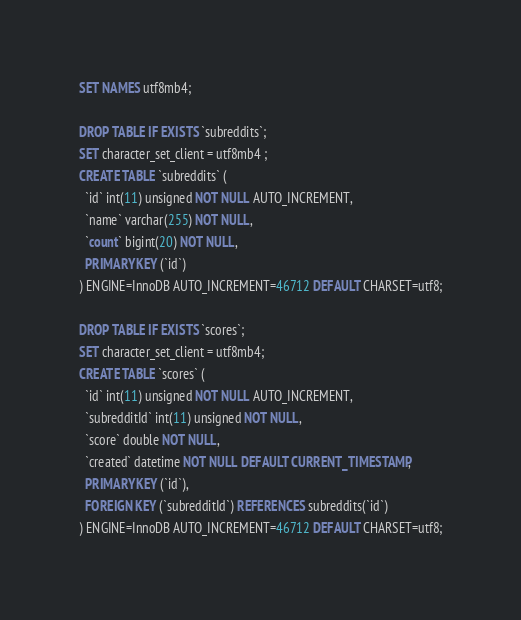Convert code to text. <code><loc_0><loc_0><loc_500><loc_500><_SQL_>SET NAMES utf8mb4;

DROP TABLE IF EXISTS `subreddits`;
SET character_set_client = utf8mb4 ;
CREATE TABLE `subreddits` (
  `id` int(11) unsigned NOT NULL AUTO_INCREMENT,
  `name` varchar(255) NOT NULL,
  `count` bigint(20) NOT NULL,
  PRIMARY KEY (`id`)
) ENGINE=InnoDB AUTO_INCREMENT=46712 DEFAULT CHARSET=utf8;

DROP TABLE IF EXISTS `scores`;
SET character_set_client = utf8mb4;
CREATE TABLE `scores` (
  `id` int(11) unsigned NOT NULL AUTO_INCREMENT,
  `subredditId` int(11) unsigned NOT NULL,
  `score` double NOT NULL,
  `created` datetime NOT NULL DEFAULT CURRENT_TIMESTAMP,
  PRIMARY KEY (`id`),
  FOREIGN KEY (`subredditId`) REFERENCES subreddits(`id`)
) ENGINE=InnoDB AUTO_INCREMENT=46712 DEFAULT CHARSET=utf8;
</code> 